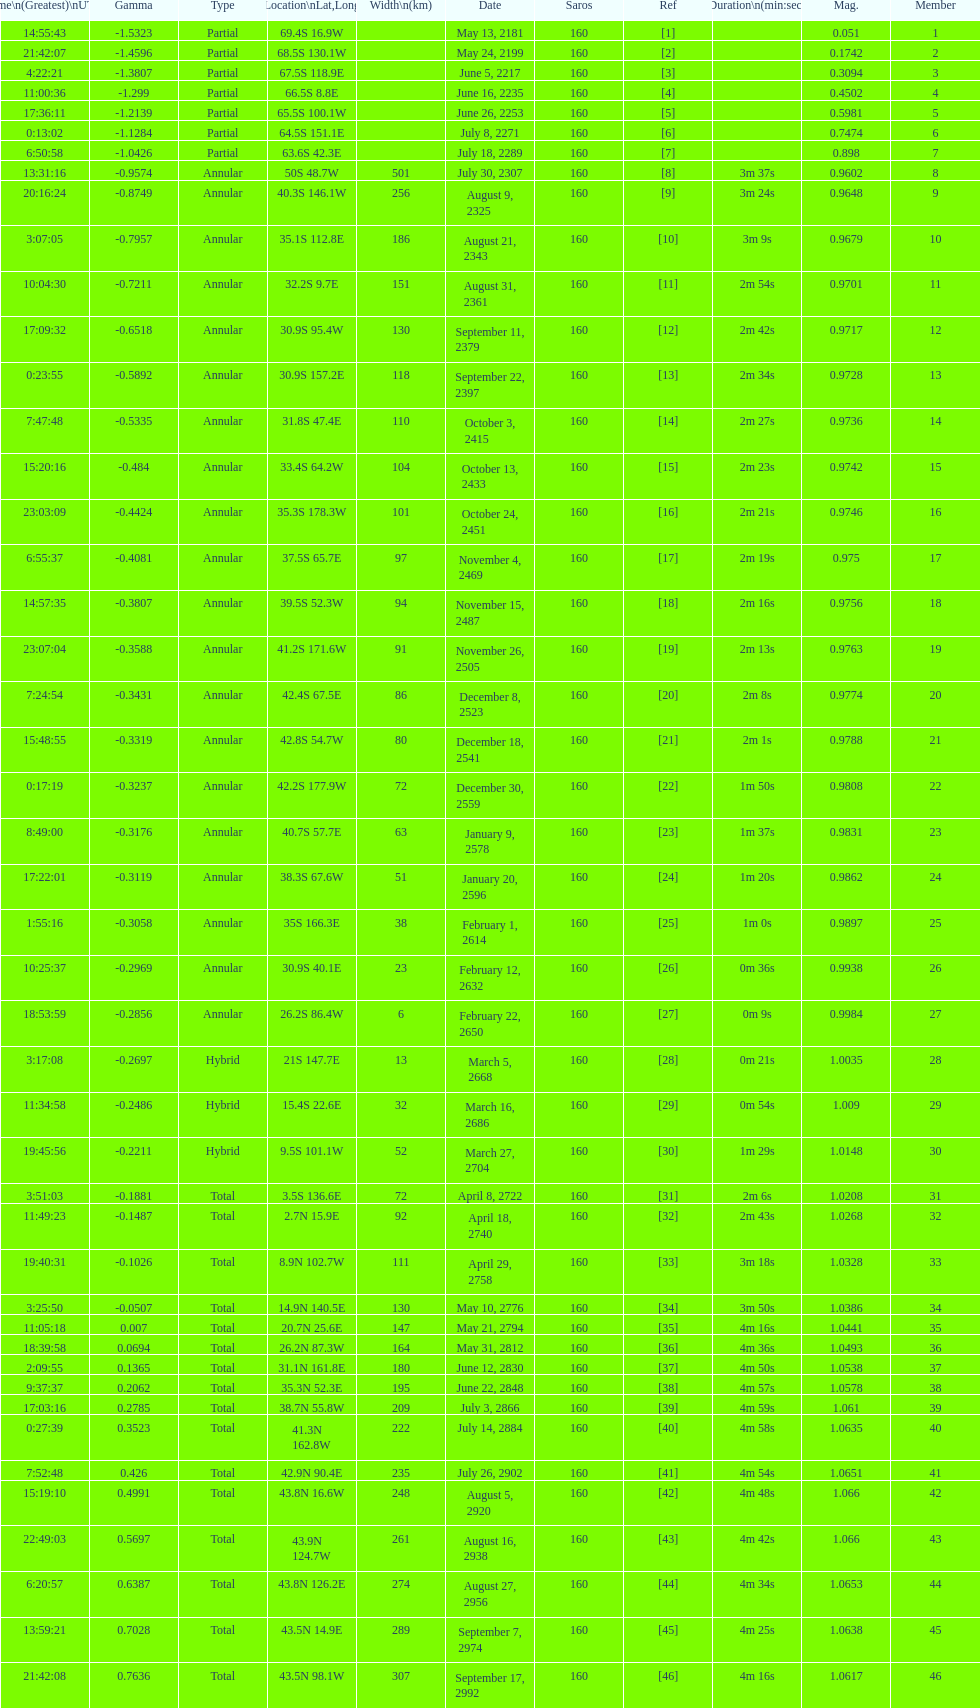How many total events will occur in all? 46. 